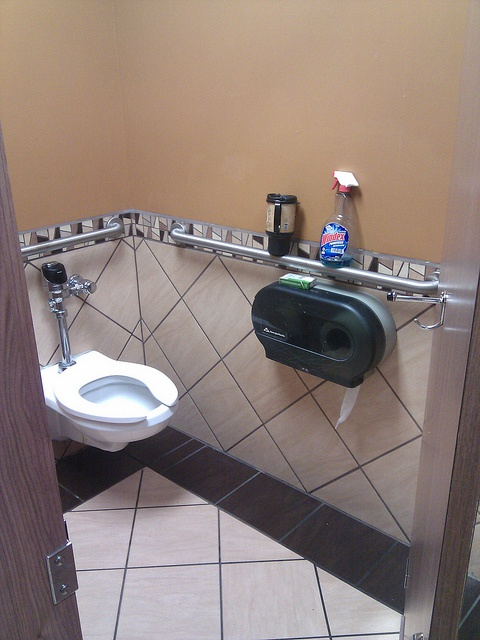Describe the objects in this image and their specific colors. I can see toilet in tan, white, gray, and darkgray tones, bottle in tan, gray, white, and navy tones, and cup in tan, black, gray, and darkgray tones in this image. 